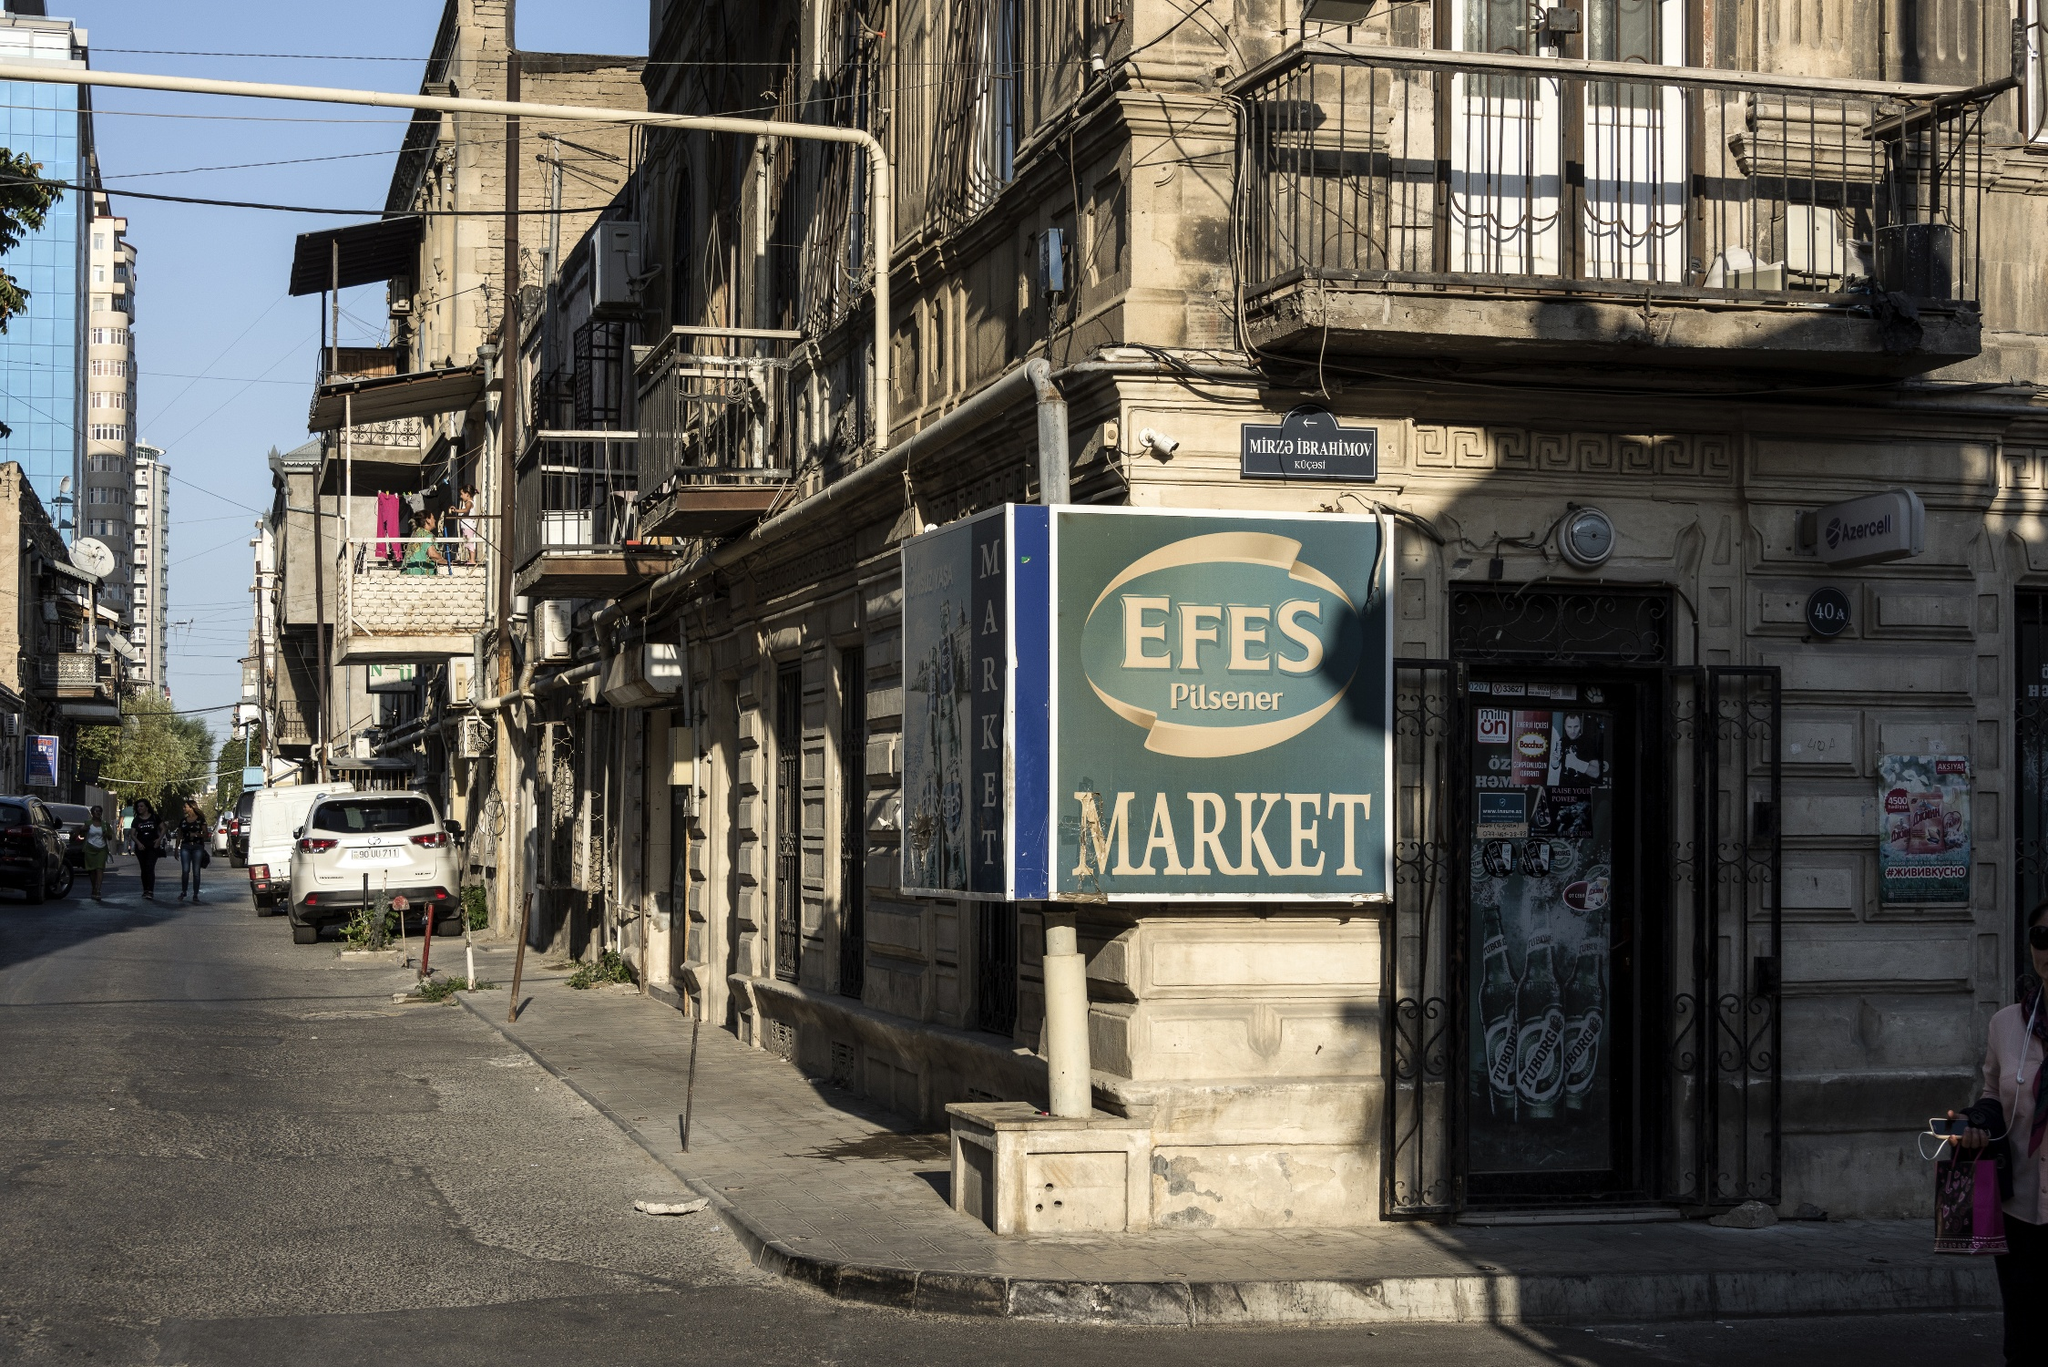What could be the challenges of living in such a busy street? Living on such a busy street might pose challenges such as dealing with constant noise from traffic, vendors, and pedestrians. The hustle and bustle could make it difficult to find moments of quiet and relaxation. Additionally, the dense population might lead to crowded living conditions and limited parking spaces, adding to daily inconveniences. The old buildings, while full of charm, may require frequent maintenance and lack modern amenities. Despite these challenges, the vibrant community and the rich cultural tapestry of the area offer a unique and enriching living experience. 